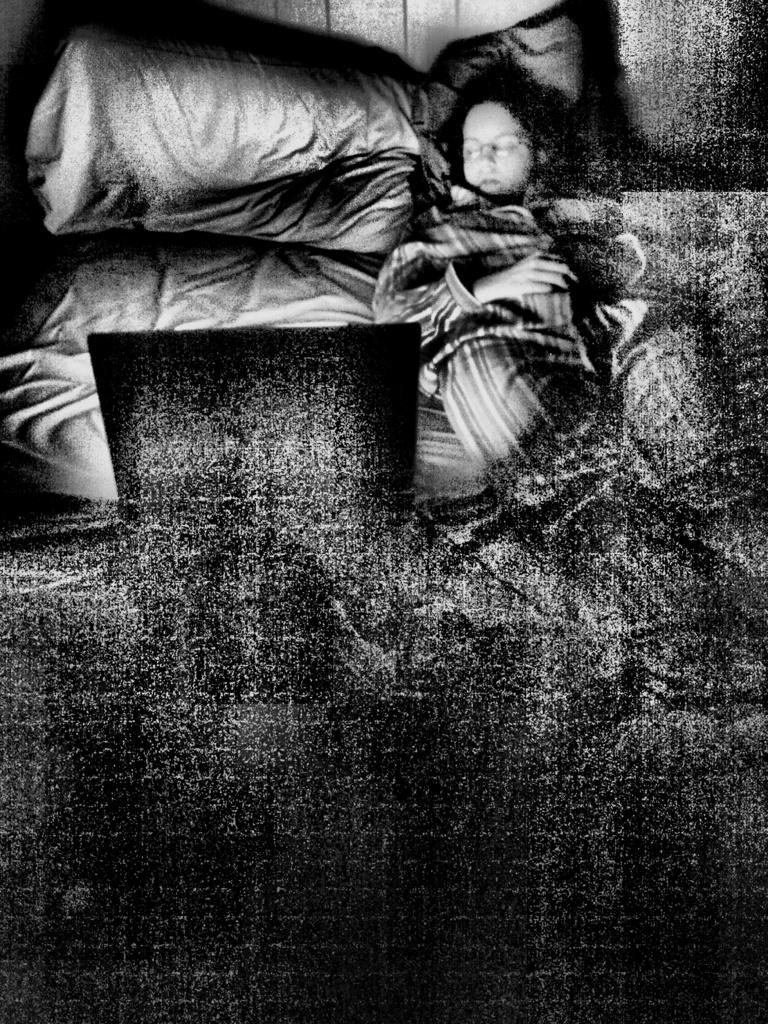What is the person in the image doing? There is a person lying on a bed in the image. What is located behind the bed? There is a pillow behind the bed in the image. What can be seen in the background of the image? There is a wall visible in the image. What type of skirt is the person wearing in the image? There is no skirt visible in the image; the person is lying on a bed. What religious beliefs does the person in the image hold? There is no information about the person's religious beliefs in the image. 